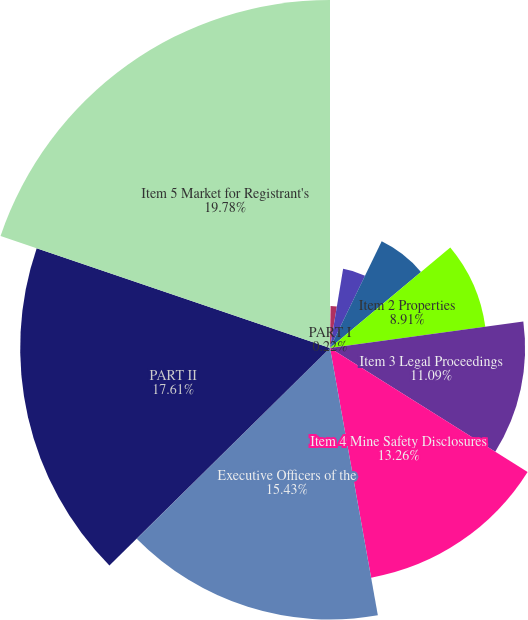<chart> <loc_0><loc_0><loc_500><loc_500><pie_chart><fcel>PART I<fcel>Item 1 Business<fcel>Item 1A Risk Factors<fcel>Item 1B Unresolved Staff<fcel>Item 2 Properties<fcel>Item 3 Legal Proceedings<fcel>Item 4 Mine Safety Disclosures<fcel>Executive Officers of the<fcel>PART II<fcel>Item 5 Market for Registrant's<nl><fcel>0.22%<fcel>2.39%<fcel>4.57%<fcel>6.74%<fcel>8.91%<fcel>11.09%<fcel>13.26%<fcel>15.43%<fcel>17.61%<fcel>19.78%<nl></chart> 